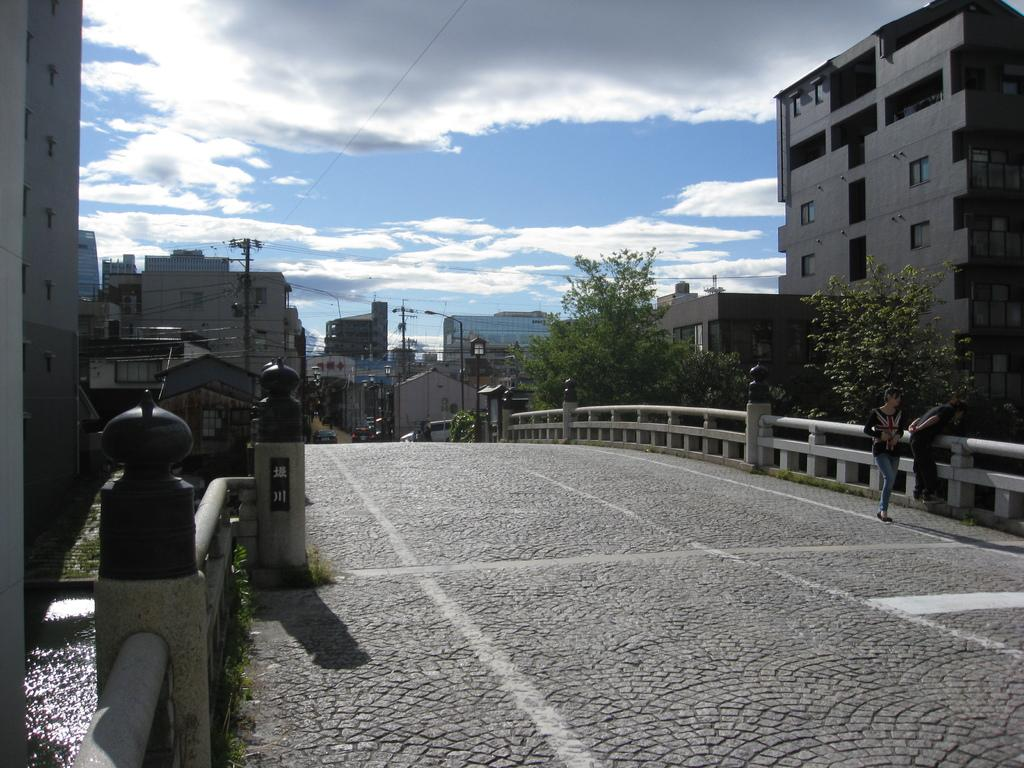What structure can be seen in the image? There is a bridge in the image. What are the people in the image doing? Two people are walking on the bridge. What type of vegetation is near the bridge? There are trees beside the bridge. What type of buildings are near the bridge? There are houses beside the bridge. What else can be seen near the bridge? Utility poles are present beside the bridge. Where is the baby playing with the hydrant in the image? There is no baby or hydrant present in the image. What type of industry can be seen near the bridge in the image? The image does not show any industry near the bridge. 